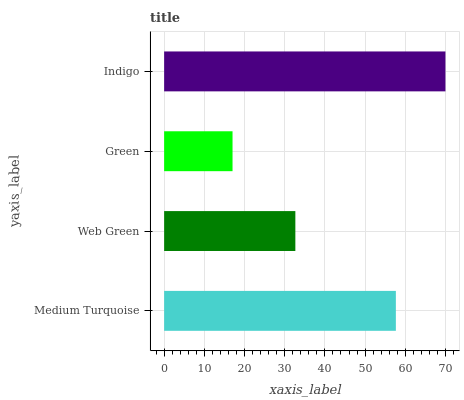Is Green the minimum?
Answer yes or no. Yes. Is Indigo the maximum?
Answer yes or no. Yes. Is Web Green the minimum?
Answer yes or no. No. Is Web Green the maximum?
Answer yes or no. No. Is Medium Turquoise greater than Web Green?
Answer yes or no. Yes. Is Web Green less than Medium Turquoise?
Answer yes or no. Yes. Is Web Green greater than Medium Turquoise?
Answer yes or no. No. Is Medium Turquoise less than Web Green?
Answer yes or no. No. Is Medium Turquoise the high median?
Answer yes or no. Yes. Is Web Green the low median?
Answer yes or no. Yes. Is Indigo the high median?
Answer yes or no. No. Is Green the low median?
Answer yes or no. No. 